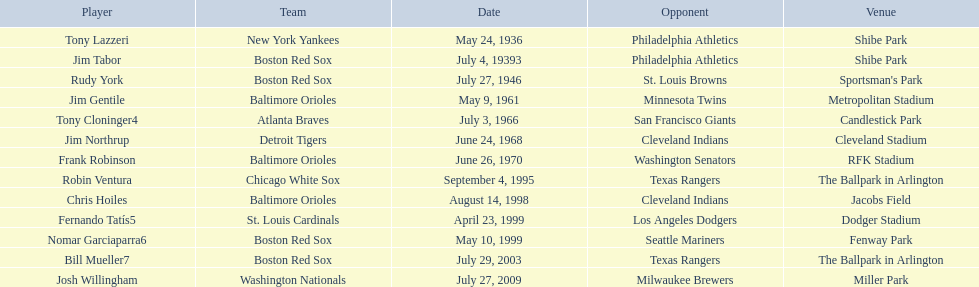What are the calendar days? May 24, 1936, July 4, 19393, July 27, 1946, May 9, 1961, July 3, 1966, June 24, 1968, June 26, 1970, September 4, 1995, August 14, 1998, April 23, 1999, May 10, 1999, July 29, 2003, July 27, 2009. Which calendar day is in 1936? May 24, 1936. What competitor is noted for this calendar day? Tony Lazzeri. 